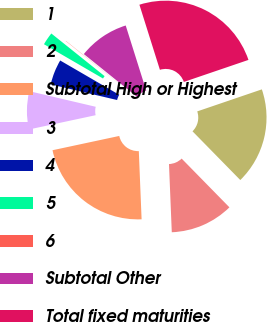Convert chart. <chart><loc_0><loc_0><loc_500><loc_500><pie_chart><fcel>1<fcel>2<fcel>Subtotal High or Highest<fcel>3<fcel>4<fcel>5<fcel>6<fcel>Subtotal Other<fcel>Total fixed maturities<nl><fcel>17.89%<fcel>11.69%<fcel>22.3%<fcel>7.03%<fcel>4.7%<fcel>2.37%<fcel>0.04%<fcel>9.36%<fcel>24.63%<nl></chart> 